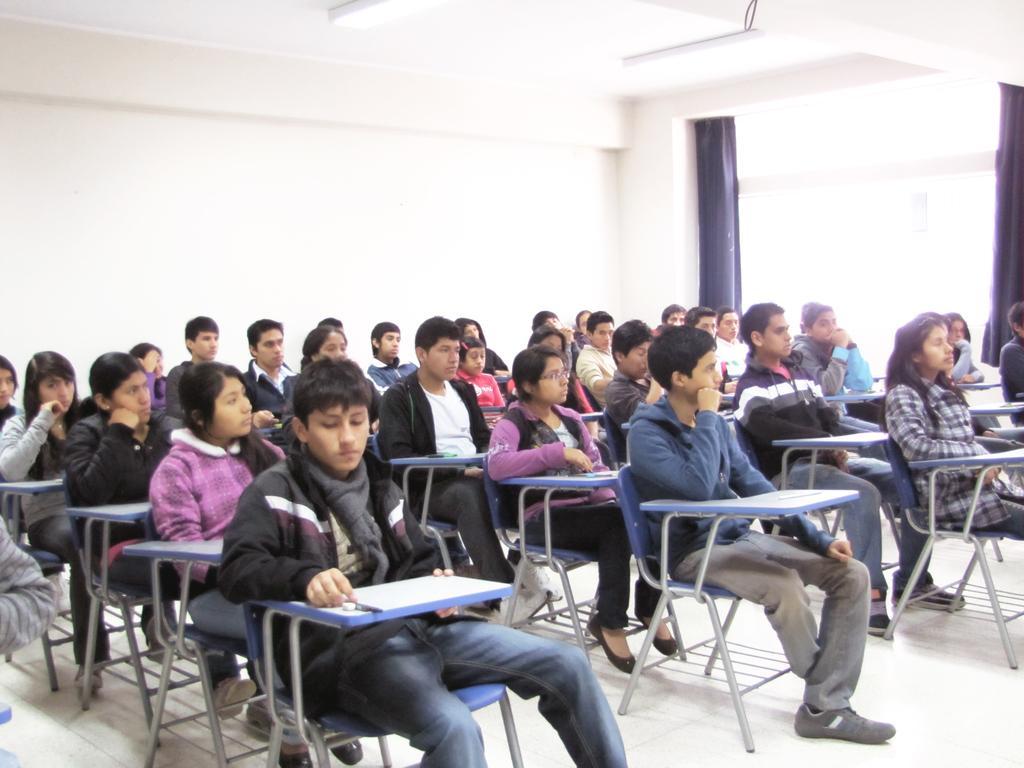How would you summarize this image in a sentence or two? In the image there are many kids sitting on chairs, in the back there is window on the wall with curtains. 